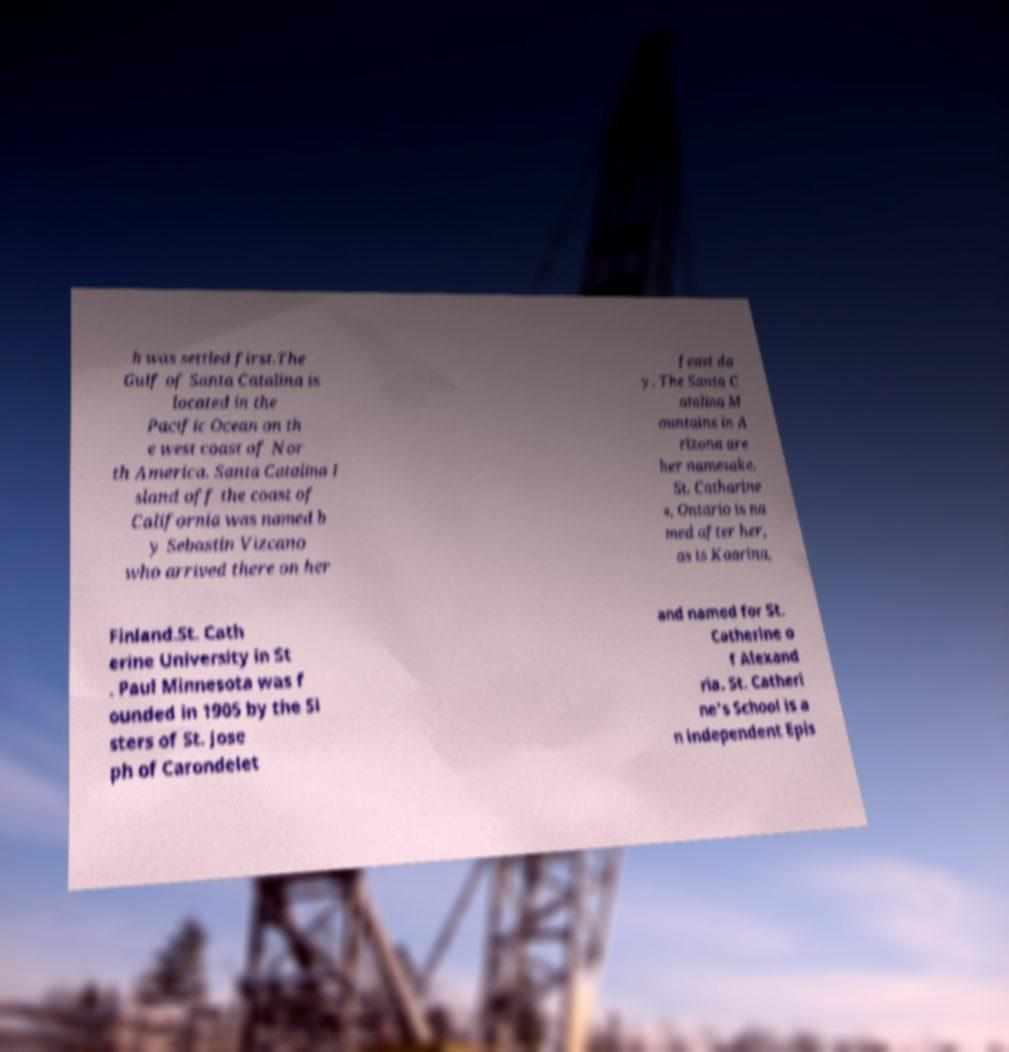There's text embedded in this image that I need extracted. Can you transcribe it verbatim? h was settled first.The Gulf of Santa Catalina is located in the Pacific Ocean on th e west coast of Nor th America. Santa Catalina I sland off the coast of California was named b y Sebastin Vizcano who arrived there on her feast da y. The Santa C atalina M ountains in A rizona are her namesake. St. Catharine s, Ontario is na med after her, as is Kaarina, Finland.St. Cath erine University in St . Paul Minnesota was f ounded in 1905 by the Si sters of St. Jose ph of Carondelet and named for St. Catherine o f Alexand ria. St. Catheri ne's School is a n independent Epis 